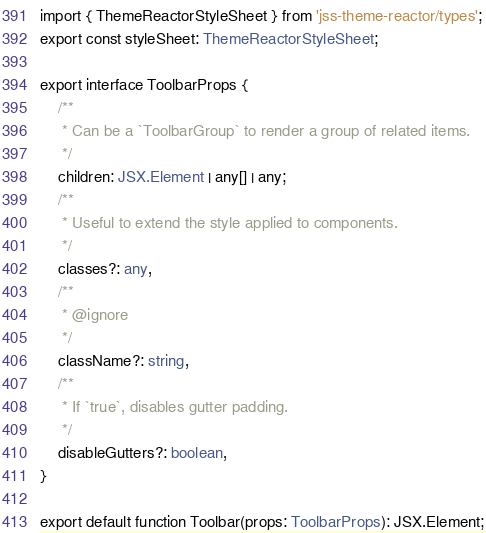Convert code to text. <code><loc_0><loc_0><loc_500><loc_500><_TypeScript_>import { ThemeReactorStyleSheet } from 'jss-theme-reactor/types';
export const styleSheet: ThemeReactorStyleSheet;

export interface ToolbarProps {
    /**
     * Can be a `ToolbarGroup` to render a group of related items.
     */
    children: JSX.Element | any[] | any;
    /**
     * Useful to extend the style applied to components.
     */
    classes?: any,
    /**
     * @ignore
     */
    className?: string,
    /**
     * If `true`, disables gutter padding.
     */
    disableGutters?: boolean,
}

export default function Toolbar(props: ToolbarProps): JSX.Element;
</code> 